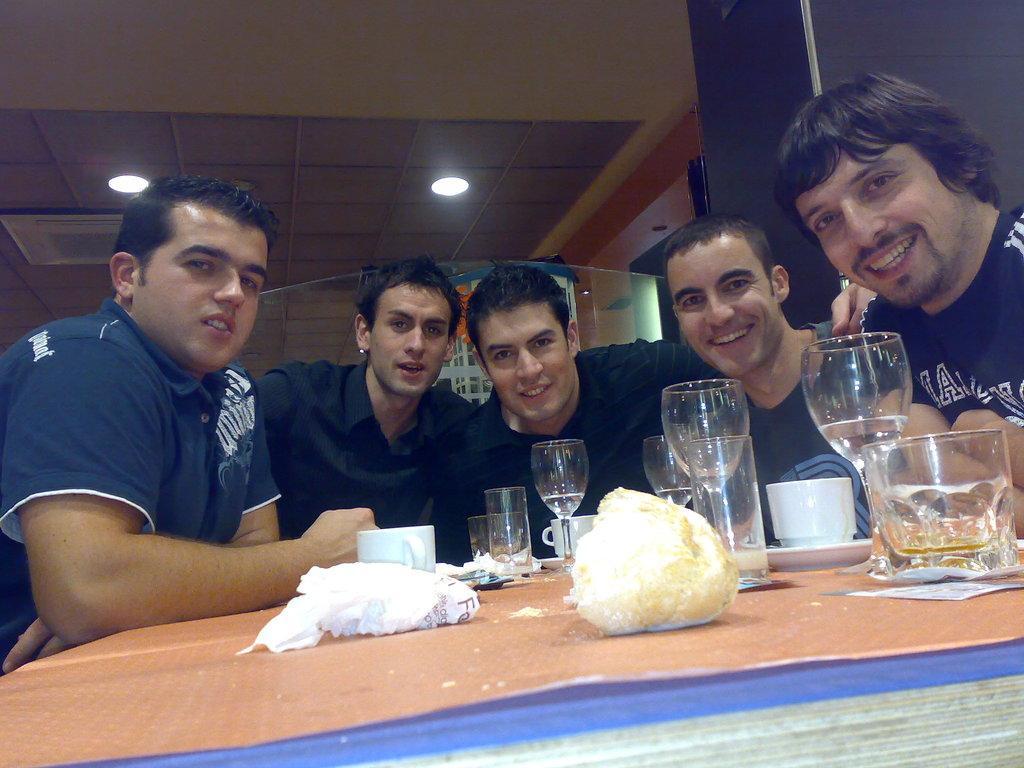In one or two sentences, can you explain what this image depicts? In this image there are people. At the bottom there is a table and we can see glasses, cups and saucers, napkin and a bread placed on the table. In the background there is a wall and we can see lights. 